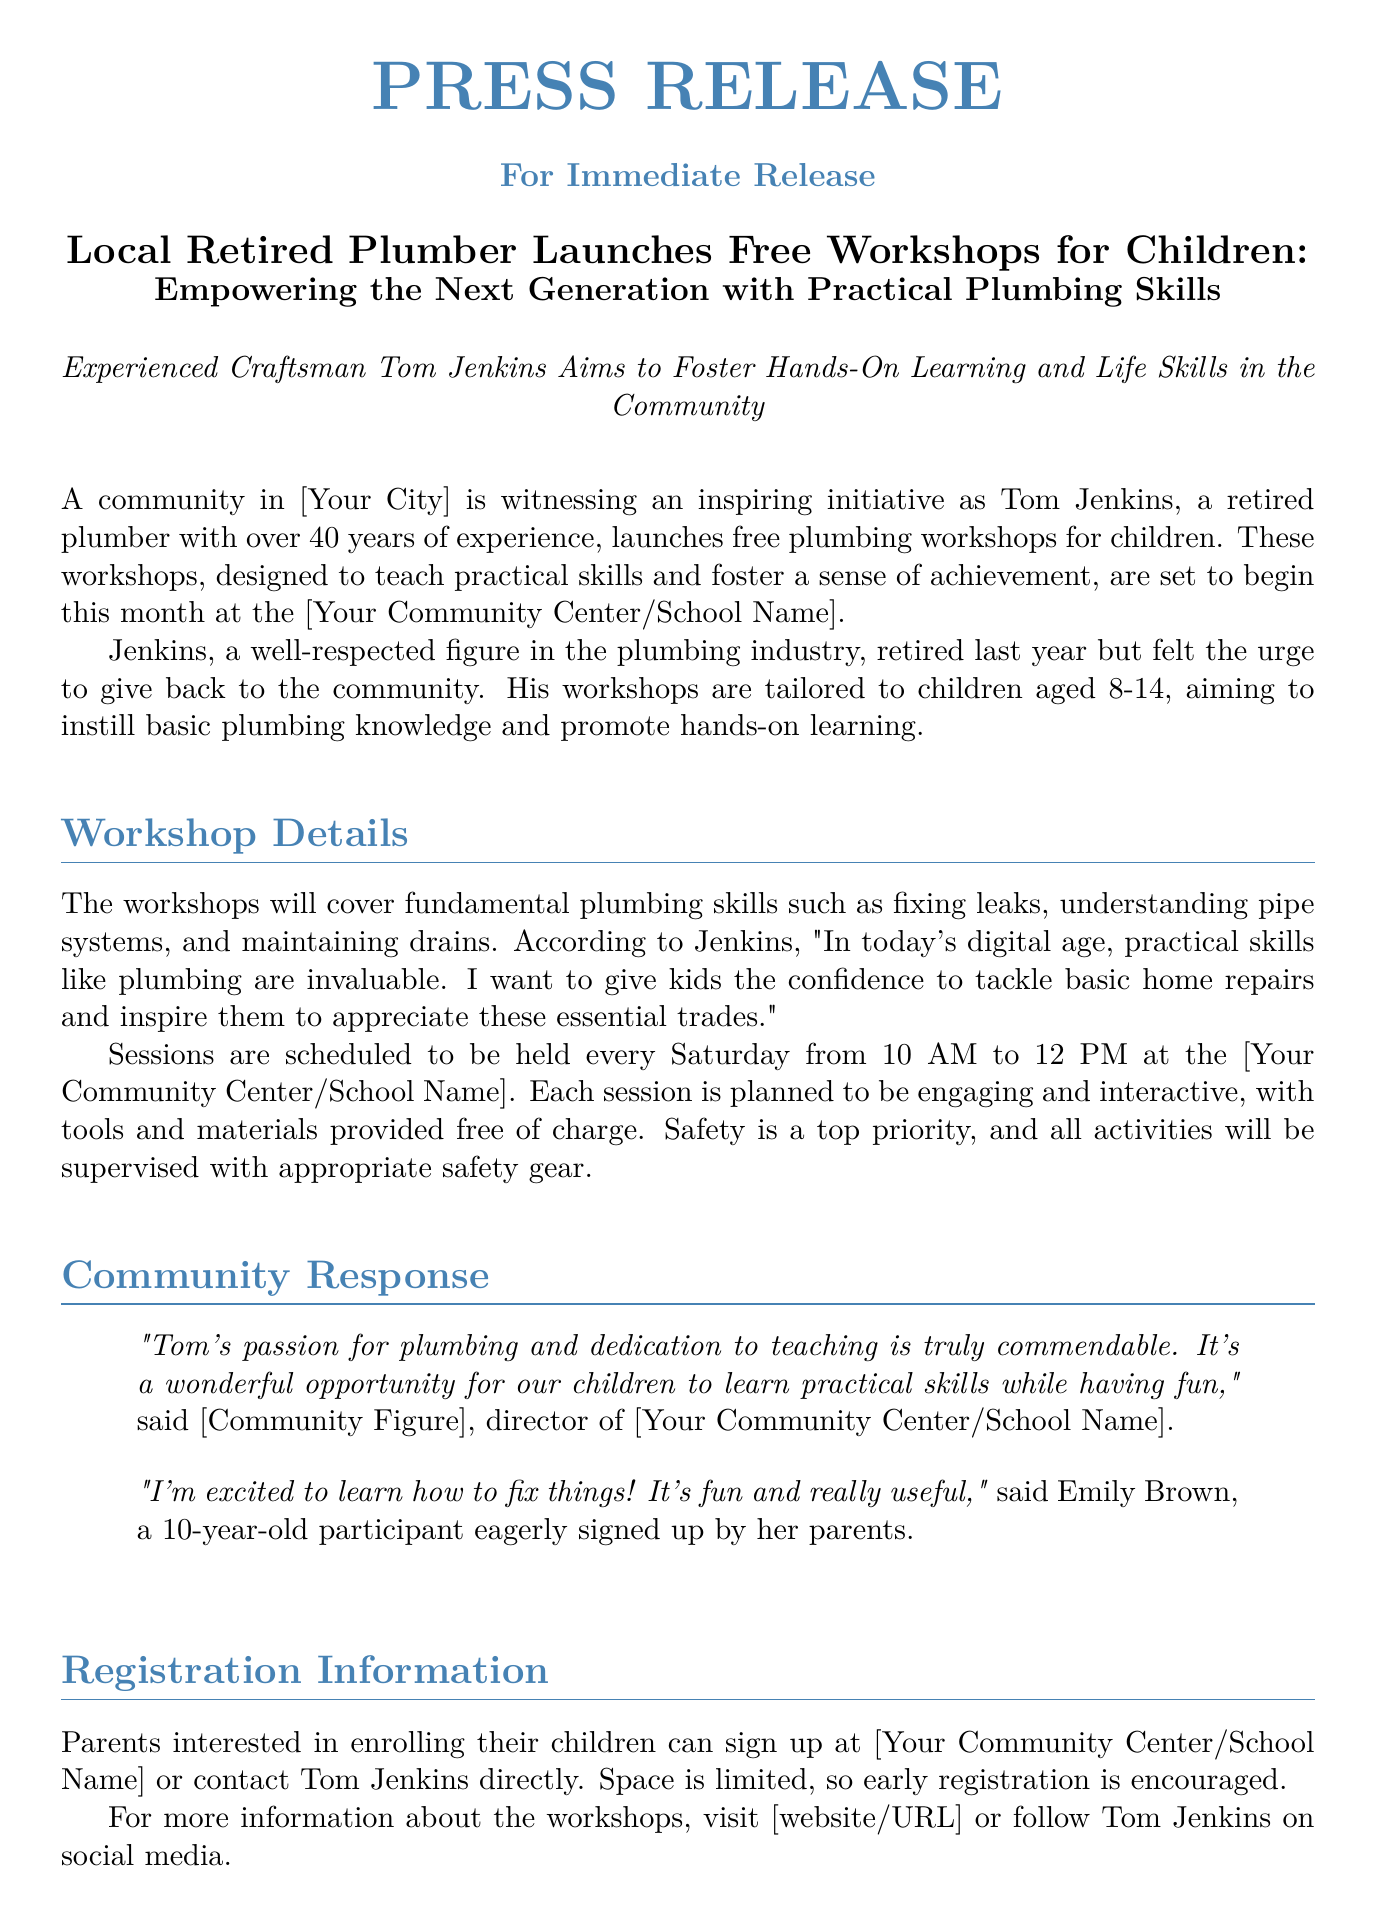What is the name of the retired plumber? The name of the retired plumber is mentioned in the press release as Tom Jenkins.
Answer: Tom Jenkins What are the ages of children targeted for the workshops? The press release specifies that the workshops are tailored to children aged 8-14.
Answer: 8-14 When do the workshops take place? The document states that the workshops are scheduled to be held every Saturday from 10 AM to 12 PM.
Answer: Every Saturday from 10 AM to 12 PM What is the primary goal of the workshops? The press release highlights that the primary goal is to instill basic plumbing knowledge and promote hands-on learning in children.
Answer: Instill basic plumbing knowledge Where can parents sign up for the workshops? The document mentions that parents can sign up at [Your Community Center/School Name].
Answer: [Your Community Center/School Name] Who expressed excitement about learning plumbing? In the press release, a 10-year-old participant named Emily Brown expressed her excitement about learning to fix things.
Answer: Emily Brown Why did Tom Jenkins decide to launch these workshops? The document indicates that Tom Jenkins felt the urge to give back to the community after retiring.
Answer: To give back to the community What is a safety measure mentioned for the workshops? The press release states that safety is a top priority, and all activities will be supervised with appropriate safety gear.
Answer: Supervised with appropriate safety gear What type of skills will the workshops cover? The workshops will cover fundamental plumbing skills such as fixing leaks, understanding pipe systems, and maintaining drains.
Answer: Fixing leaks, understanding pipe systems, maintaining drains 